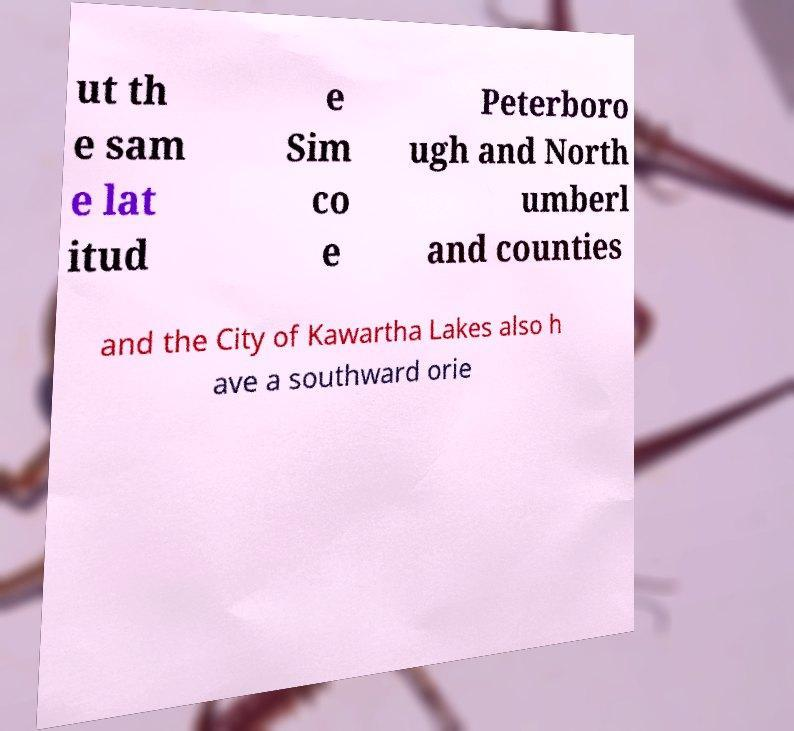For documentation purposes, I need the text within this image transcribed. Could you provide that? ut th e sam e lat itud e Sim co e Peterboro ugh and North umberl and counties and the City of Kawartha Lakes also h ave a southward orie 